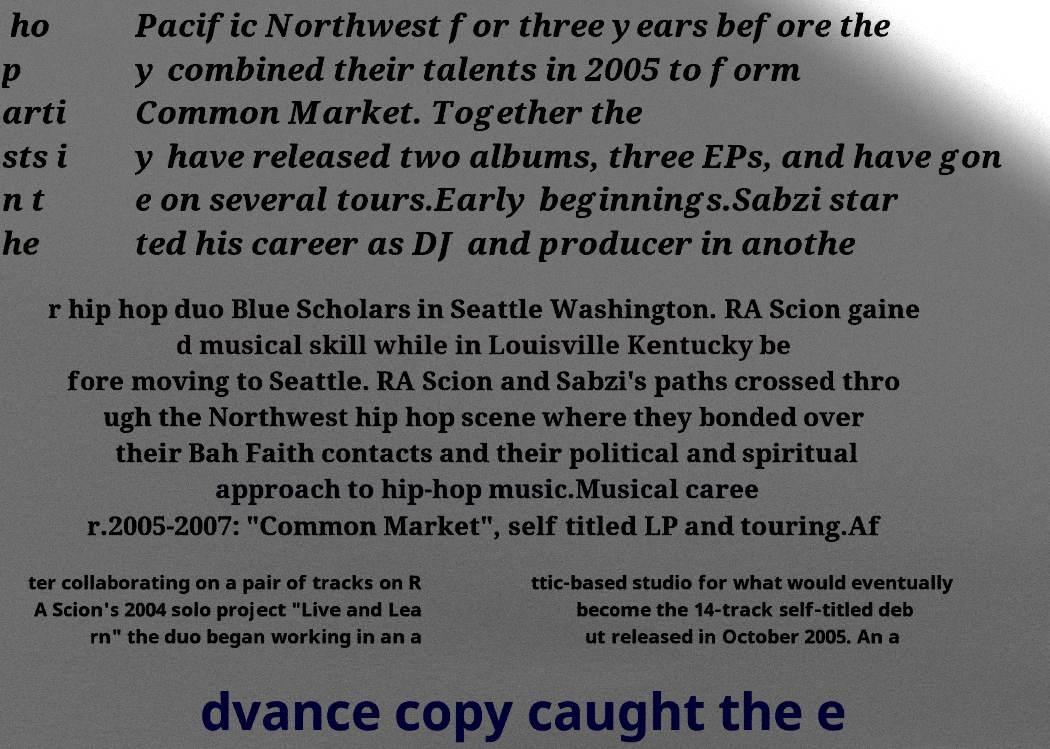What messages or text are displayed in this image? I need them in a readable, typed format. ho p arti sts i n t he Pacific Northwest for three years before the y combined their talents in 2005 to form Common Market. Together the y have released two albums, three EPs, and have gon e on several tours.Early beginnings.Sabzi star ted his career as DJ and producer in anothe r hip hop duo Blue Scholars in Seattle Washington. RA Scion gaine d musical skill while in Louisville Kentucky be fore moving to Seattle. RA Scion and Sabzi's paths crossed thro ugh the Northwest hip hop scene where they bonded over their Bah Faith contacts and their political and spiritual approach to hip-hop music.Musical caree r.2005-2007: "Common Market", self titled LP and touring.Af ter collaborating on a pair of tracks on R A Scion's 2004 solo project "Live and Lea rn" the duo began working in an a ttic-based studio for what would eventually become the 14-track self-titled deb ut released in October 2005. An a dvance copy caught the e 